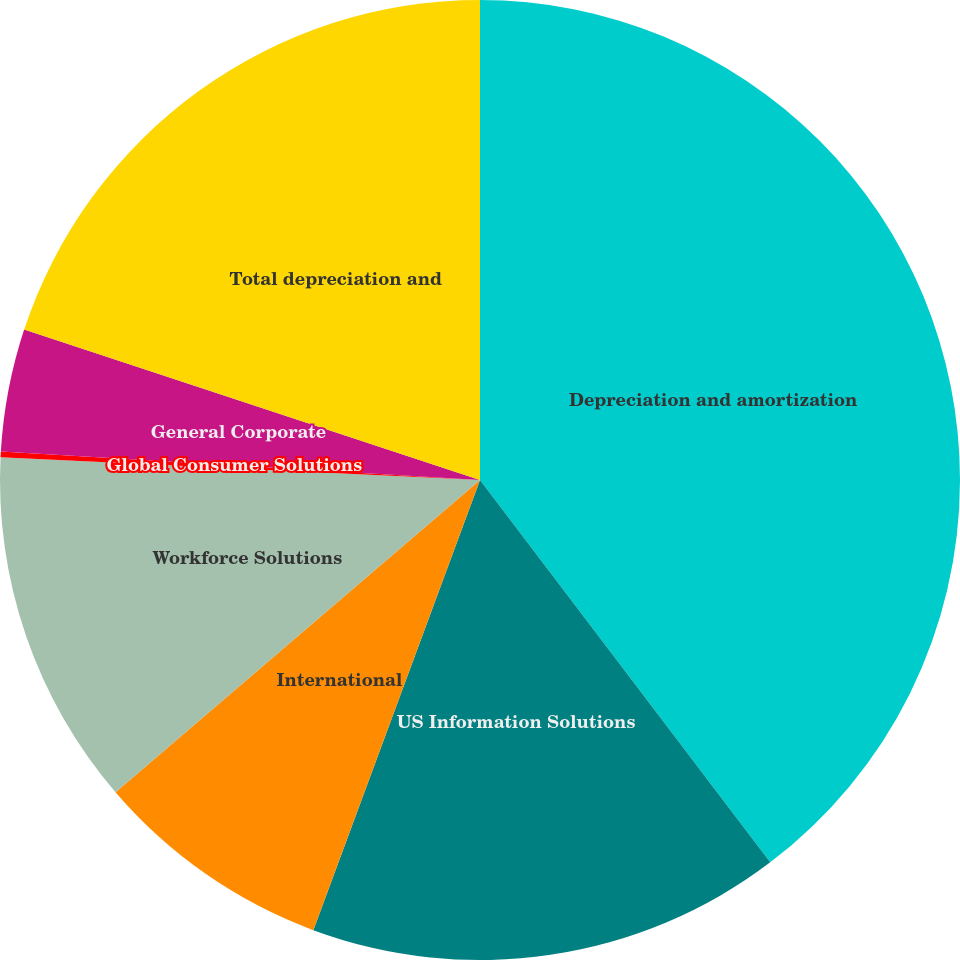Convert chart to OTSL. <chart><loc_0><loc_0><loc_500><loc_500><pie_chart><fcel>Depreciation and amortization<fcel>US Information Solutions<fcel>International<fcel>Workforce Solutions<fcel>Global Consumer Solutions<fcel>General Corporate<fcel>Total depreciation and<nl><fcel>39.67%<fcel>15.98%<fcel>8.08%<fcel>12.03%<fcel>0.19%<fcel>4.13%<fcel>19.93%<nl></chart> 